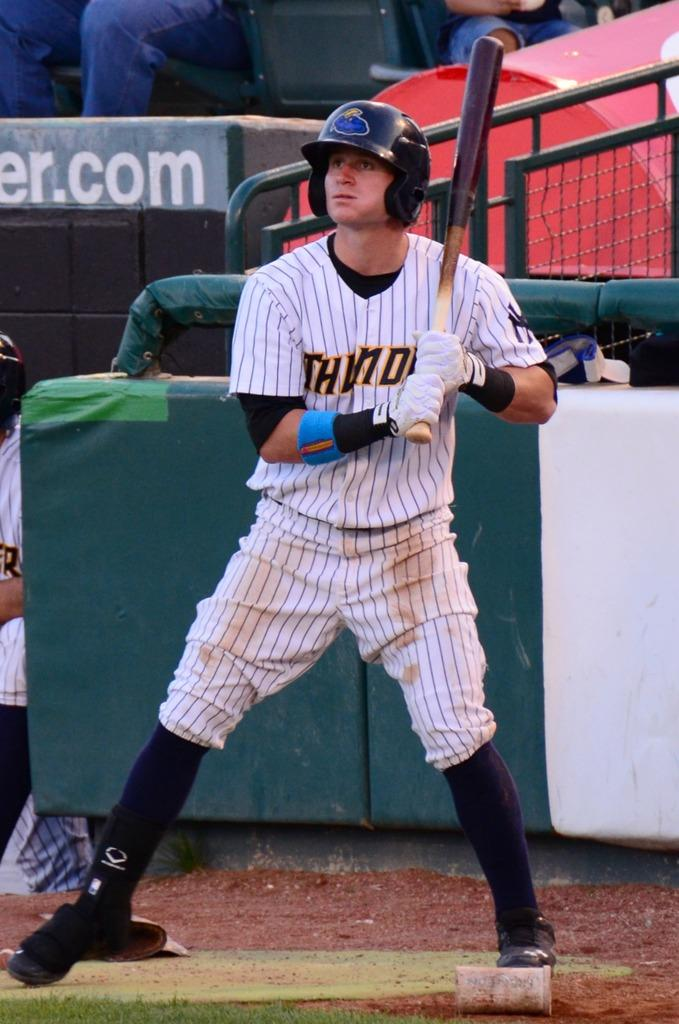<image>
Describe the image concisely. A man wearing a Thunder uniform holds a baseball bat. 